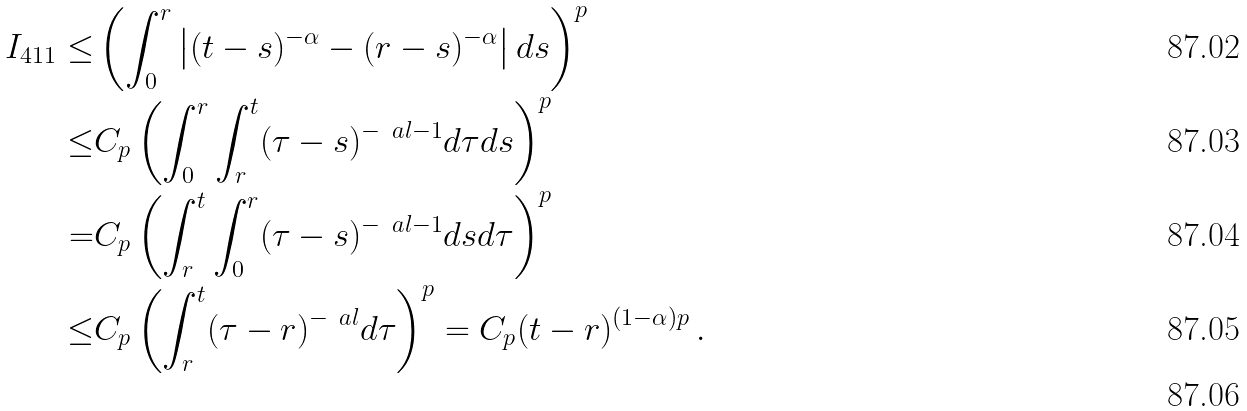Convert formula to latex. <formula><loc_0><loc_0><loc_500><loc_500>I _ { 4 1 1 } \leq & \left ( \int _ { 0 } ^ { r } \left | ( t - s ) ^ { - \alpha } - ( r - s ) ^ { - \alpha } \right | d s \right ) ^ { p } \\ \leq & C _ { p } \left ( \int _ { 0 } ^ { r } \int _ { r } ^ { t } ( \tau - s ) ^ { - \ a l - 1 } d \tau d s \right ) ^ { p } \\ = & C _ { p } \left ( \int _ { r } ^ { t } \int _ { 0 } ^ { r } ( \tau - s ) ^ { - \ a l - 1 } d s d \tau \right ) ^ { p } \\ \leq & C _ { p } \left ( \int _ { r } ^ { t } ( \tau - r ) ^ { - \ a l } d \tau \right ) ^ { p } = C _ { p } ( t - r ) ^ { ( 1 - \alpha ) p } \, . \\</formula> 